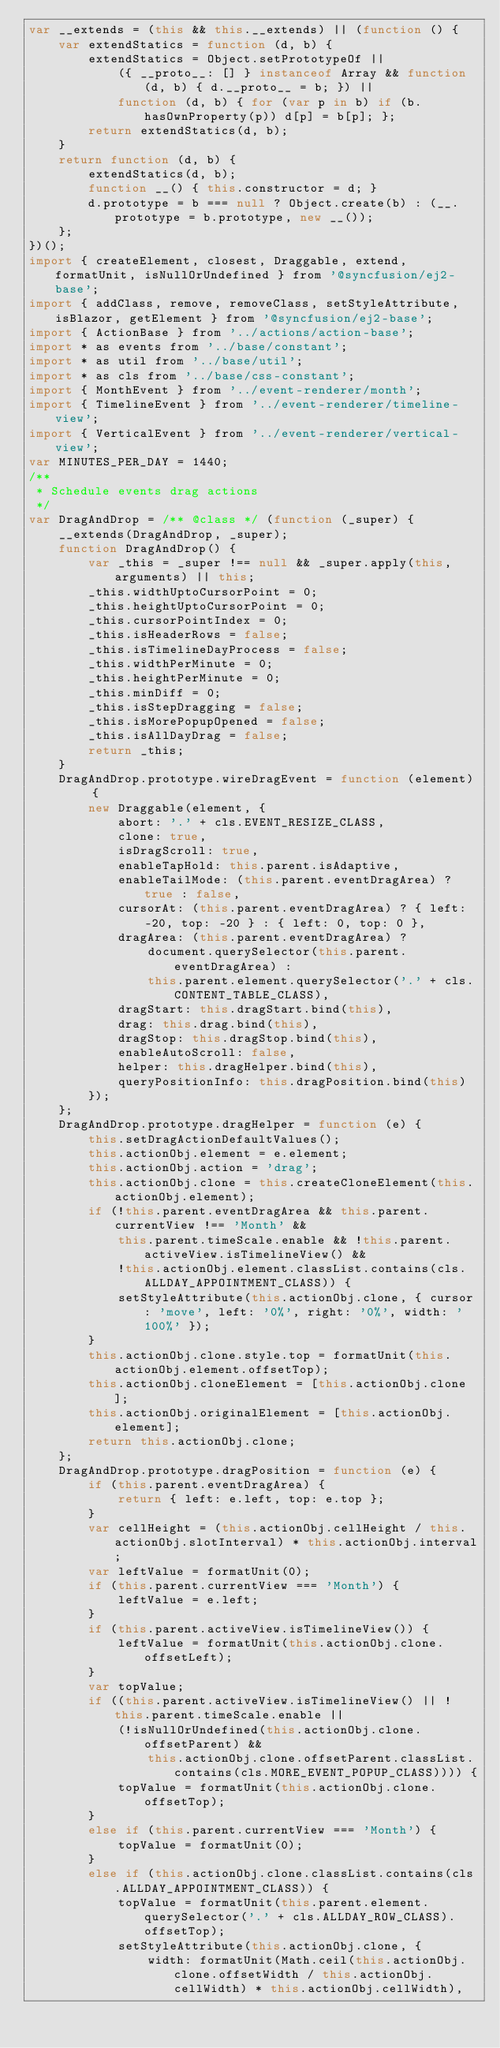<code> <loc_0><loc_0><loc_500><loc_500><_JavaScript_>var __extends = (this && this.__extends) || (function () {
    var extendStatics = function (d, b) {
        extendStatics = Object.setPrototypeOf ||
            ({ __proto__: [] } instanceof Array && function (d, b) { d.__proto__ = b; }) ||
            function (d, b) { for (var p in b) if (b.hasOwnProperty(p)) d[p] = b[p]; };
        return extendStatics(d, b);
    }
    return function (d, b) {
        extendStatics(d, b);
        function __() { this.constructor = d; }
        d.prototype = b === null ? Object.create(b) : (__.prototype = b.prototype, new __());
    };
})();
import { createElement, closest, Draggable, extend, formatUnit, isNullOrUndefined } from '@syncfusion/ej2-base';
import { addClass, remove, removeClass, setStyleAttribute, isBlazor, getElement } from '@syncfusion/ej2-base';
import { ActionBase } from '../actions/action-base';
import * as events from '../base/constant';
import * as util from '../base/util';
import * as cls from '../base/css-constant';
import { MonthEvent } from '../event-renderer/month';
import { TimelineEvent } from '../event-renderer/timeline-view';
import { VerticalEvent } from '../event-renderer/vertical-view';
var MINUTES_PER_DAY = 1440;
/**
 * Schedule events drag actions
 */
var DragAndDrop = /** @class */ (function (_super) {
    __extends(DragAndDrop, _super);
    function DragAndDrop() {
        var _this = _super !== null && _super.apply(this, arguments) || this;
        _this.widthUptoCursorPoint = 0;
        _this.heightUptoCursorPoint = 0;
        _this.cursorPointIndex = 0;
        _this.isHeaderRows = false;
        _this.isTimelineDayProcess = false;
        _this.widthPerMinute = 0;
        _this.heightPerMinute = 0;
        _this.minDiff = 0;
        _this.isStepDragging = false;
        _this.isMorePopupOpened = false;
        _this.isAllDayDrag = false;
        return _this;
    }
    DragAndDrop.prototype.wireDragEvent = function (element) {
        new Draggable(element, {
            abort: '.' + cls.EVENT_RESIZE_CLASS,
            clone: true,
            isDragScroll: true,
            enableTapHold: this.parent.isAdaptive,
            enableTailMode: (this.parent.eventDragArea) ? true : false,
            cursorAt: (this.parent.eventDragArea) ? { left: -20, top: -20 } : { left: 0, top: 0 },
            dragArea: (this.parent.eventDragArea) ?
                document.querySelector(this.parent.eventDragArea) :
                this.parent.element.querySelector('.' + cls.CONTENT_TABLE_CLASS),
            dragStart: this.dragStart.bind(this),
            drag: this.drag.bind(this),
            dragStop: this.dragStop.bind(this),
            enableAutoScroll: false,
            helper: this.dragHelper.bind(this),
            queryPositionInfo: this.dragPosition.bind(this)
        });
    };
    DragAndDrop.prototype.dragHelper = function (e) {
        this.setDragActionDefaultValues();
        this.actionObj.element = e.element;
        this.actionObj.action = 'drag';
        this.actionObj.clone = this.createCloneElement(this.actionObj.element);
        if (!this.parent.eventDragArea && this.parent.currentView !== 'Month' &&
            this.parent.timeScale.enable && !this.parent.activeView.isTimelineView() &&
            !this.actionObj.element.classList.contains(cls.ALLDAY_APPOINTMENT_CLASS)) {
            setStyleAttribute(this.actionObj.clone, { cursor: 'move', left: '0%', right: '0%', width: '100%' });
        }
        this.actionObj.clone.style.top = formatUnit(this.actionObj.element.offsetTop);
        this.actionObj.cloneElement = [this.actionObj.clone];
        this.actionObj.originalElement = [this.actionObj.element];
        return this.actionObj.clone;
    };
    DragAndDrop.prototype.dragPosition = function (e) {
        if (this.parent.eventDragArea) {
            return { left: e.left, top: e.top };
        }
        var cellHeight = (this.actionObj.cellHeight / this.actionObj.slotInterval) * this.actionObj.interval;
        var leftValue = formatUnit(0);
        if (this.parent.currentView === 'Month') {
            leftValue = e.left;
        }
        if (this.parent.activeView.isTimelineView()) {
            leftValue = formatUnit(this.actionObj.clone.offsetLeft);
        }
        var topValue;
        if ((this.parent.activeView.isTimelineView() || !this.parent.timeScale.enable ||
            (!isNullOrUndefined(this.actionObj.clone.offsetParent) &&
                this.actionObj.clone.offsetParent.classList.contains(cls.MORE_EVENT_POPUP_CLASS)))) {
            topValue = formatUnit(this.actionObj.clone.offsetTop);
        }
        else if (this.parent.currentView === 'Month') {
            topValue = formatUnit(0);
        }
        else if (this.actionObj.clone.classList.contains(cls.ALLDAY_APPOINTMENT_CLASS)) {
            topValue = formatUnit(this.parent.element.querySelector('.' + cls.ALLDAY_ROW_CLASS).offsetTop);
            setStyleAttribute(this.actionObj.clone, {
                width: formatUnit(Math.ceil(this.actionObj.clone.offsetWidth / this.actionObj.cellWidth) * this.actionObj.cellWidth),</code> 